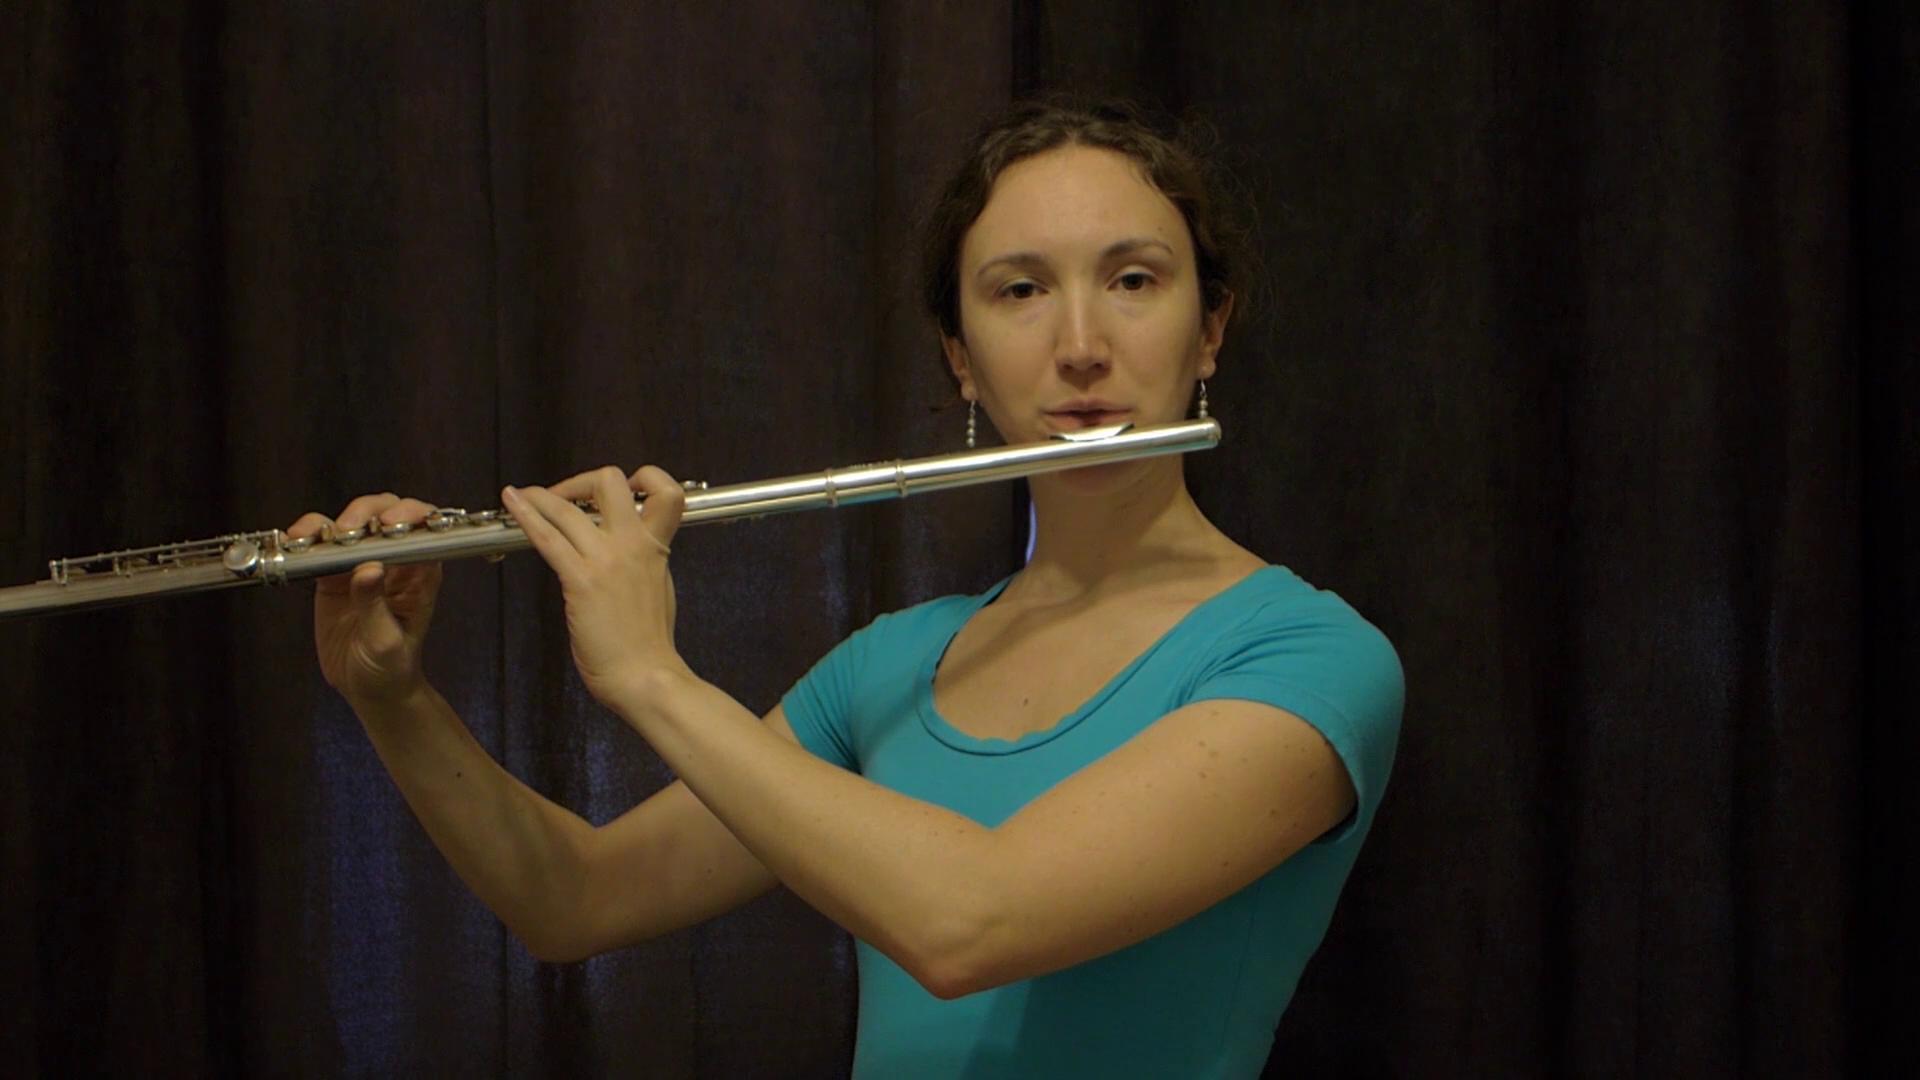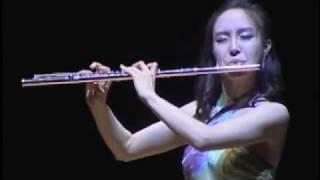The first image is the image on the left, the second image is the image on the right. Examine the images to the left and right. Is the description "In at least one image there is a woman with long hair  holding but no playing the flute." accurate? Answer yes or no. No. The first image is the image on the left, the second image is the image on the right. For the images shown, is this caption "A woman smiles while she holds a flute in one of the images." true? Answer yes or no. No. 